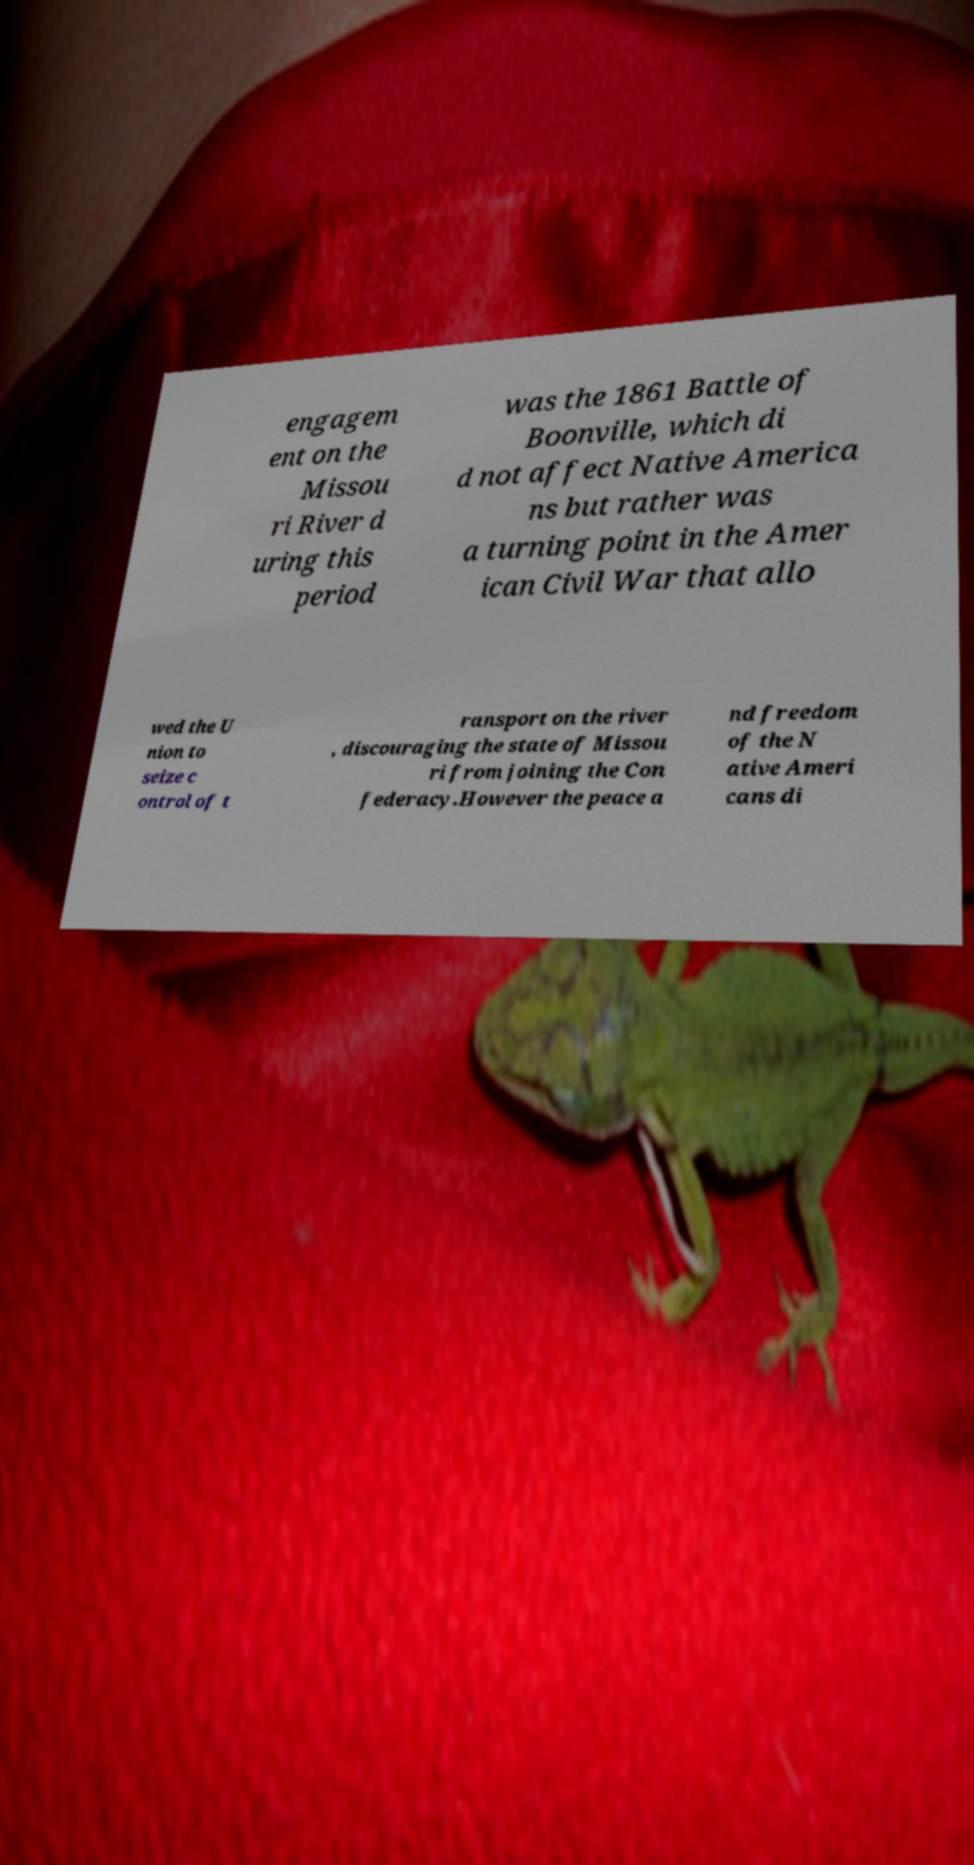Please identify and transcribe the text found in this image. engagem ent on the Missou ri River d uring this period was the 1861 Battle of Boonville, which di d not affect Native America ns but rather was a turning point in the Amer ican Civil War that allo wed the U nion to seize c ontrol of t ransport on the river , discouraging the state of Missou ri from joining the Con federacy.However the peace a nd freedom of the N ative Ameri cans di 